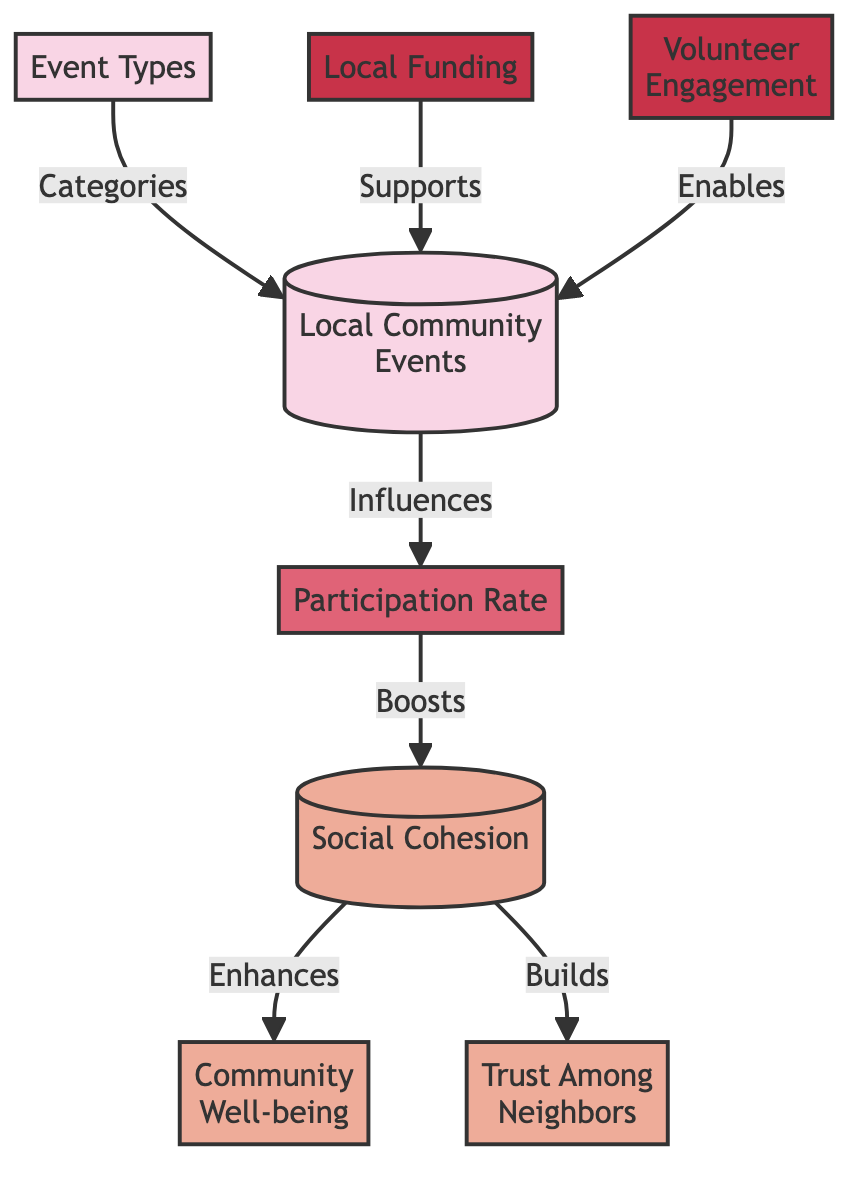What is the first node listed in the diagram? The first node is "Local Community Events," which is found at the top of the diagram.
Answer: Local Community Events How many outcome nodes are present in the diagram? There are three outcome nodes: "Social Cohesion," "Trust Among Neighbors," and "Community Well-being." By counting these nodes, we determine that the total is three.
Answer: 3 Which node influences the "Participation Rate"? The "Local Community Events" node influences the "Participation Rate." This is indicated by the direct edge connecting the two nodes marked with the label "Influences."
Answer: Local Community Events What does the "Participation Rate" boost? The "Participation Rate" boosts "Social Cohesion" according to the directional influence represented in the diagram.
Answer: Social Cohesion Which element enables "Local Community Events"? The "Volunteer Engagement" element enables "Local Community Events," as indicated by the edge labeled "Enables."
Answer: Volunteer Engagement What is the relationship between "Social Cohesion" and "Community Well-being"? "Social Cohesion" enhances "Community Well-being," based on the flow shown in the diagram.
Answer: Enhances What are the types of nodes present in this diagram? The types of nodes present in the diagram include event nodes, outcome nodes, a metric node, and input nodes. Each type serves a distinct role represented by the edge connections.
Answer: event, outcome, metric, input Which input directly supports "Local Community Events"? "Local Funding" directly supports "Local Community Events," as it is directly connected to it by an edge labeled "Supports."
Answer: Local Funding How many edges are present that connect input nodes to the "Local Community Events"? There are two edges connecting input nodes to the "Local Community Events": one from "Local Funding" and one from "Volunteer Engagement." This can be verified by tracking the connections from those specific nodes.
Answer: 2 